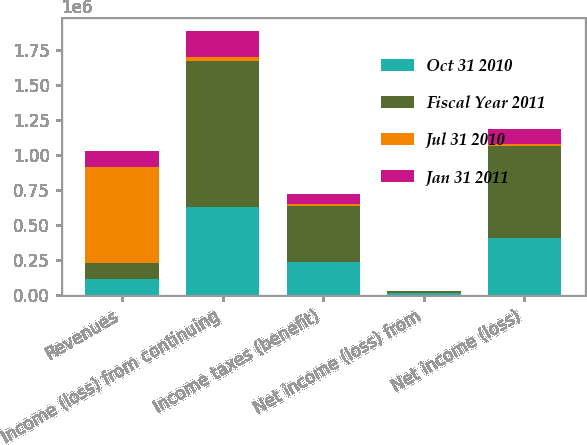Convert chart. <chart><loc_0><loc_0><loc_500><loc_500><stacked_bar_chart><ecel><fcel>Revenues<fcel>Income (loss) from continuing<fcel>Income taxes (benefit)<fcel>Net income (loss) from<fcel>Net income (loss)<nl><fcel>Oct 31 2010<fcel>115517<fcel>627703<fcel>235156<fcel>13563<fcel>406110<nl><fcel>Fiscal Year 2011<fcel>115517<fcel>1.04434e+06<fcel>401505<fcel>15728<fcel>658561<nl><fcel>Jul 31 2010<fcel>680296<fcel>25968<fcel>14934<fcel>1687<fcel>12721<nl><fcel>Jan 31 2011<fcel>119590<fcel>183516<fcel>72072<fcel>2395<fcel>109049<nl></chart> 